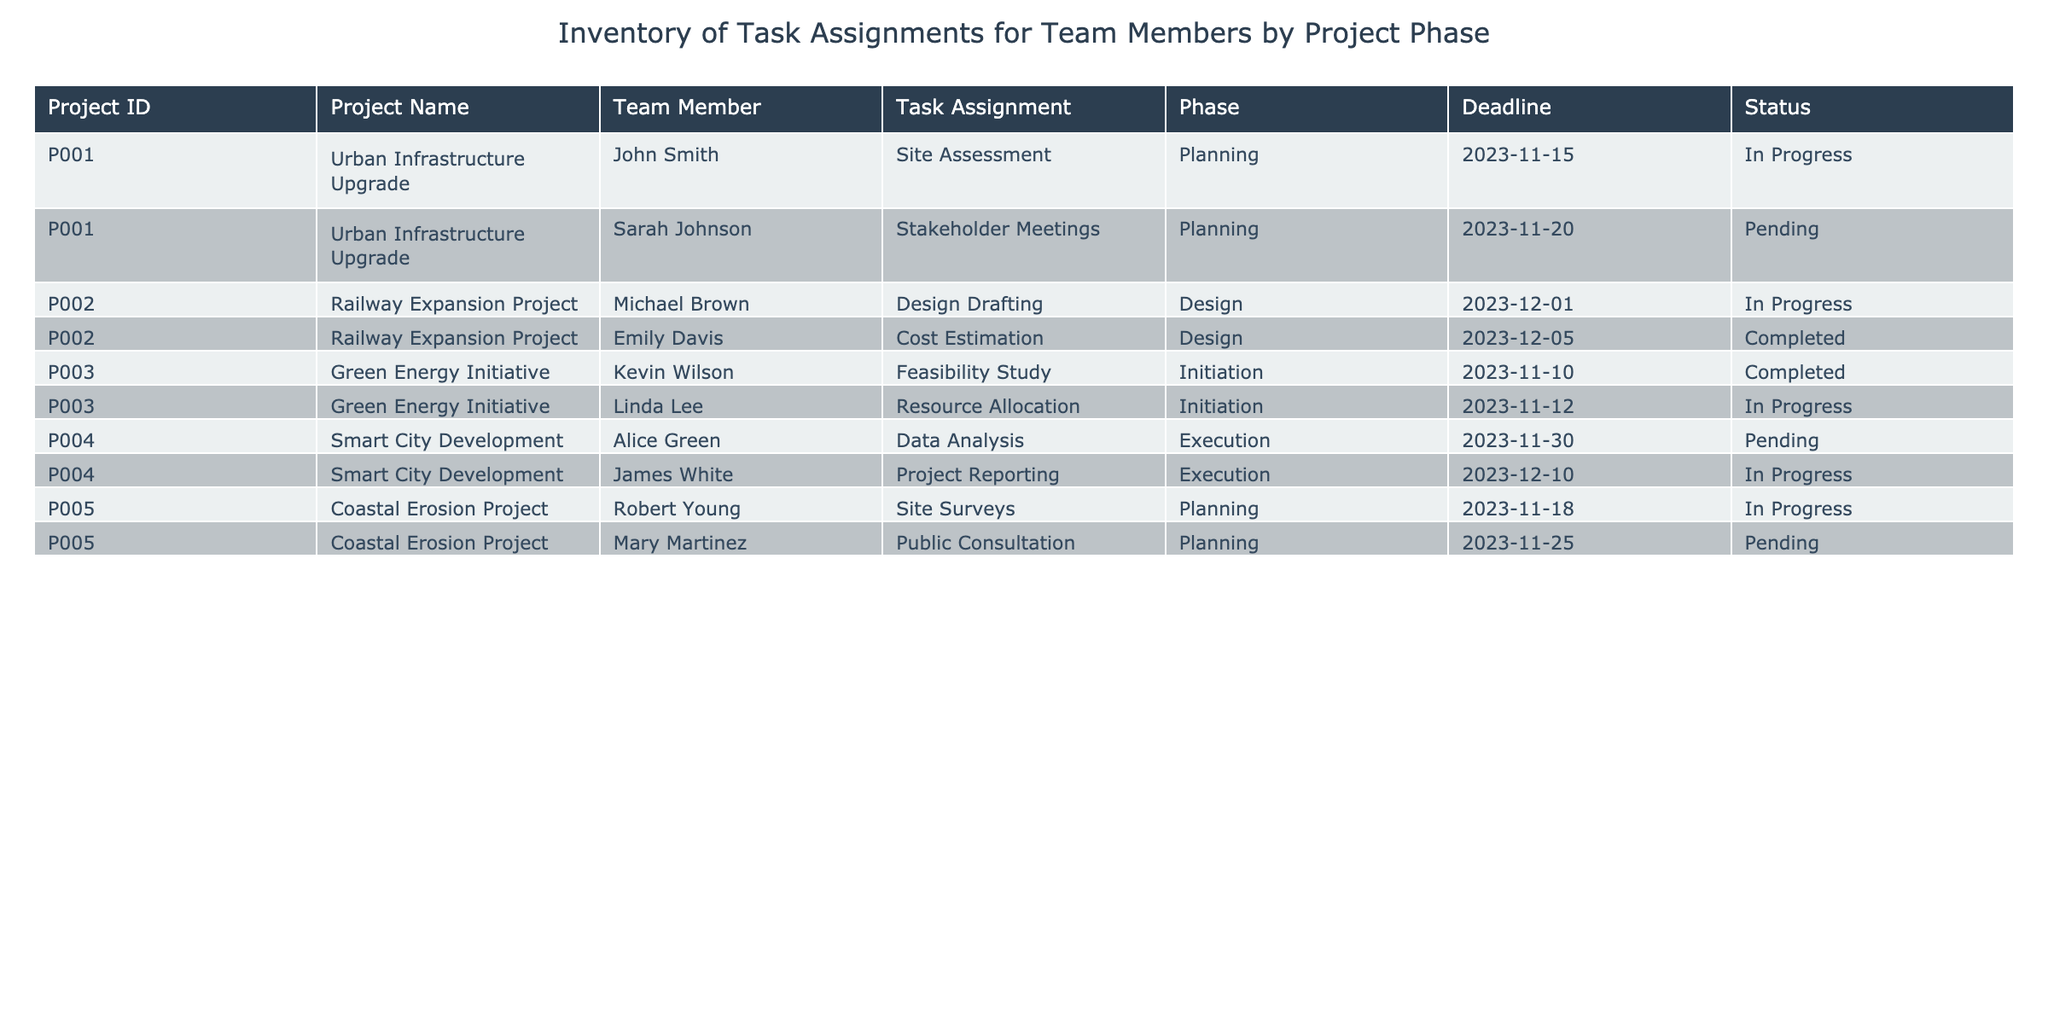What is the status of the task assignment for John Smith? The table indicates that John's task assignment of "Site Assessment" under the project "Urban Infrastructure Upgrade" is in the status "In Progress."
Answer: In Progress How many tasks are currently in the "Planning" phase? There are a total of three tasks in the "Planning" phase: "Site Assessment" by John Smith, "Stakeholder Meetings" by Sarah Johnson, and "Site Surveys" by Robert Young.
Answer: 3 Is Emily Davis's task completed? The table shows that Emily Davis's task, "Cost Estimation," under the project "Railway Expansion Project," has a status of "Completed."
Answer: Yes What is the earliest deadline across all tasks? By reviewing the deadlines, the earliest is for the task "Feasibility Study" by Kevin Wilson, which is due on 2023-11-10.
Answer: 2023-11-10 Which team member has the latest deadline? By analyzing the deadlines, James White's task "Project Reporting" has the latest deadline of 2023-12-10, compared to the others.
Answer: James White What percentage of tasks in the "Execution" phase are still pending? There are 2 tasks in the "Execution" phase: "Data Analysis" by Alice Green (Pending) and "Project Reporting" by James White (In Progress). This means 1 out of 2 is pending, resulting in (1/2)*100 = 50%.
Answer: 50% What are the task assignments of the team members working on the "Design" phase? The table outlines two assignments in the "Design" phase: Michael Brown with "Design Drafting" and Emily Davis with "Cost Estimation."
Answer: Michael Brown (Design Drafting), Emily Davis (Cost Estimation) How many tasks are marked as "Pending" across all projects? By reviewing the table, there are three tasks marked as "Pending": Sarah Johnson (Stakeholder Meetings), Alice Green (Data Analysis), and Mary Martinez (Public Consultation).
Answer: 3 What is the task assigned to Linda Lee, and what is its current status? The table shows that Linda Lee is assigned the "Resource Allocation" task, which is currently "In Progress."
Answer: Resource Allocation, In Progress 